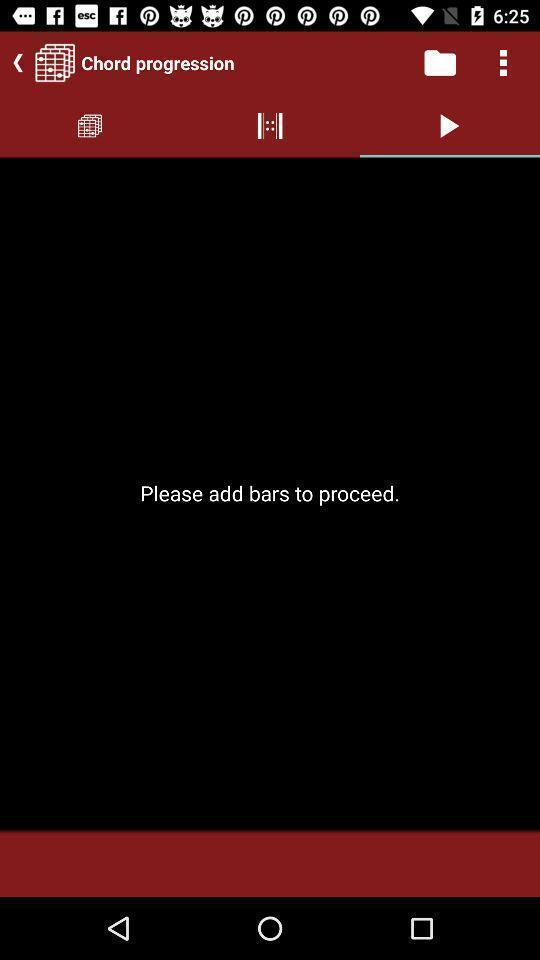Describe this image in words. Page showing different songs available. 